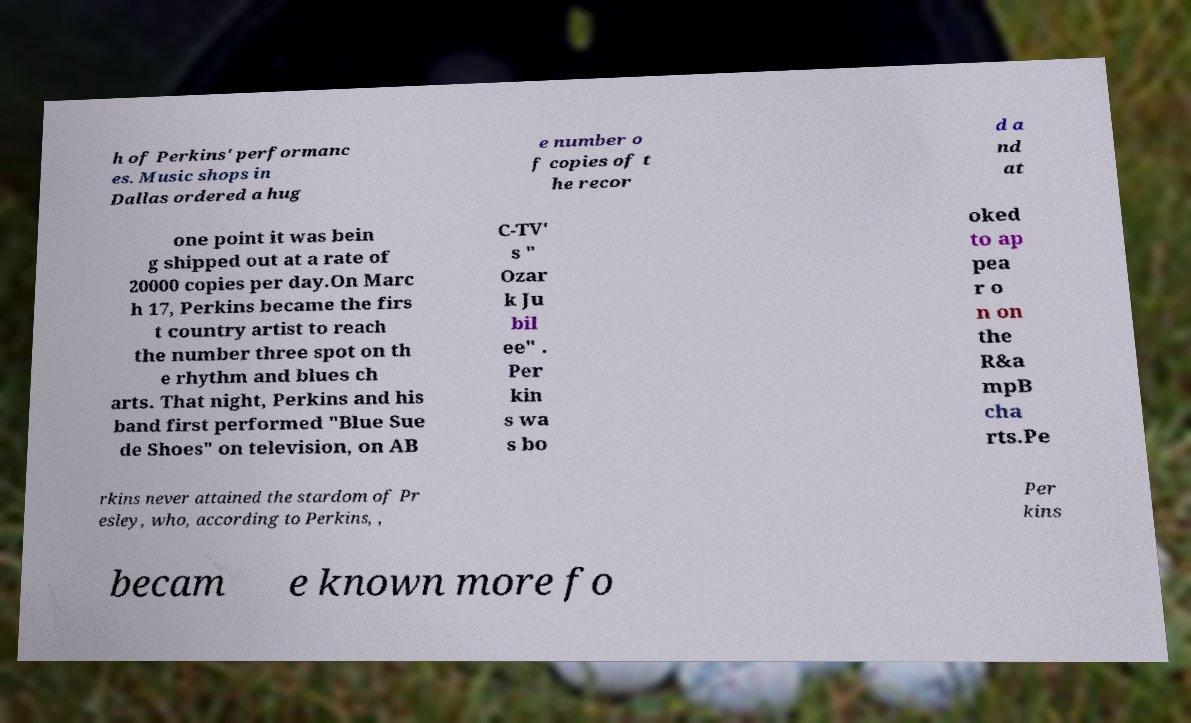For documentation purposes, I need the text within this image transcribed. Could you provide that? h of Perkins' performanc es. Music shops in Dallas ordered a hug e number o f copies of t he recor d a nd at one point it was bein g shipped out at a rate of 20000 copies per day.On Marc h 17, Perkins became the firs t country artist to reach the number three spot on th e rhythm and blues ch arts. That night, Perkins and his band first performed "Blue Sue de Shoes" on television, on AB C-TV' s " Ozar k Ju bil ee" . Per kin s wa s bo oked to ap pea r o n on the R&a mpB cha rts.Pe rkins never attained the stardom of Pr esley, who, according to Perkins, , Per kins becam e known more fo 